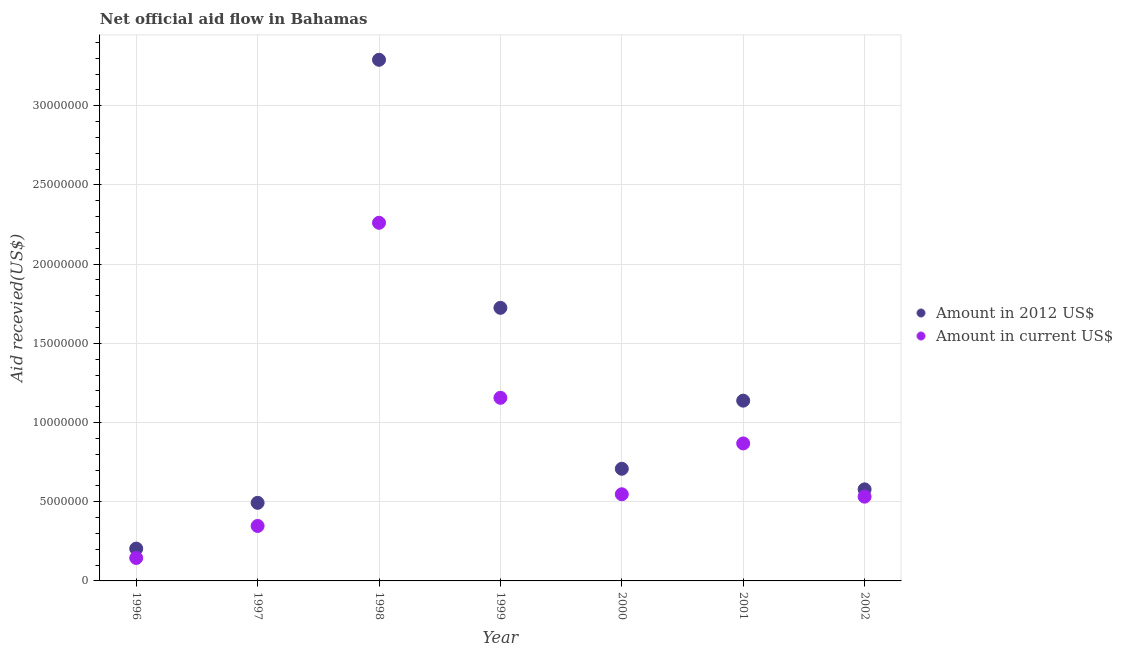What is the amount of aid received(expressed in 2012 us$) in 1997?
Ensure brevity in your answer.  4.93e+06. Across all years, what is the maximum amount of aid received(expressed in 2012 us$)?
Provide a succinct answer. 3.29e+07. Across all years, what is the minimum amount of aid received(expressed in us$)?
Keep it short and to the point. 1.45e+06. In which year was the amount of aid received(expressed in us$) minimum?
Your answer should be compact. 1996. What is the total amount of aid received(expressed in us$) in the graph?
Offer a terse response. 5.86e+07. What is the difference between the amount of aid received(expressed in us$) in 1996 and that in 2001?
Your response must be concise. -7.23e+06. What is the difference between the amount of aid received(expressed in 2012 us$) in 2001 and the amount of aid received(expressed in us$) in 1998?
Provide a succinct answer. -1.12e+07. What is the average amount of aid received(expressed in 2012 us$) per year?
Ensure brevity in your answer.  1.16e+07. In the year 2002, what is the difference between the amount of aid received(expressed in us$) and amount of aid received(expressed in 2012 us$)?
Offer a terse response. -4.60e+05. What is the ratio of the amount of aid received(expressed in us$) in 1997 to that in 2000?
Provide a succinct answer. 0.63. Is the amount of aid received(expressed in 2012 us$) in 1998 less than that in 2001?
Your answer should be very brief. No. What is the difference between the highest and the second highest amount of aid received(expressed in us$)?
Offer a very short reply. 1.10e+07. What is the difference between the highest and the lowest amount of aid received(expressed in 2012 us$)?
Your response must be concise. 3.09e+07. Is the amount of aid received(expressed in 2012 us$) strictly greater than the amount of aid received(expressed in us$) over the years?
Offer a terse response. Yes. Is the amount of aid received(expressed in 2012 us$) strictly less than the amount of aid received(expressed in us$) over the years?
Provide a succinct answer. No. How many years are there in the graph?
Your answer should be compact. 7. What is the difference between two consecutive major ticks on the Y-axis?
Keep it short and to the point. 5.00e+06. Where does the legend appear in the graph?
Provide a succinct answer. Center right. How are the legend labels stacked?
Offer a terse response. Vertical. What is the title of the graph?
Your answer should be compact. Net official aid flow in Bahamas. What is the label or title of the Y-axis?
Make the answer very short. Aid recevied(US$). What is the Aid recevied(US$) of Amount in 2012 US$ in 1996?
Your response must be concise. 2.04e+06. What is the Aid recevied(US$) of Amount in current US$ in 1996?
Provide a succinct answer. 1.45e+06. What is the Aid recevied(US$) of Amount in 2012 US$ in 1997?
Your answer should be very brief. 4.93e+06. What is the Aid recevied(US$) of Amount in current US$ in 1997?
Offer a very short reply. 3.47e+06. What is the Aid recevied(US$) of Amount in 2012 US$ in 1998?
Give a very brief answer. 3.29e+07. What is the Aid recevied(US$) in Amount in current US$ in 1998?
Provide a short and direct response. 2.26e+07. What is the Aid recevied(US$) of Amount in 2012 US$ in 1999?
Provide a short and direct response. 1.72e+07. What is the Aid recevied(US$) in Amount in current US$ in 1999?
Make the answer very short. 1.16e+07. What is the Aid recevied(US$) of Amount in 2012 US$ in 2000?
Give a very brief answer. 7.08e+06. What is the Aid recevied(US$) in Amount in current US$ in 2000?
Provide a succinct answer. 5.47e+06. What is the Aid recevied(US$) in Amount in 2012 US$ in 2001?
Provide a succinct answer. 1.14e+07. What is the Aid recevied(US$) in Amount in current US$ in 2001?
Give a very brief answer. 8.68e+06. What is the Aid recevied(US$) of Amount in 2012 US$ in 2002?
Ensure brevity in your answer.  5.78e+06. What is the Aid recevied(US$) in Amount in current US$ in 2002?
Offer a terse response. 5.32e+06. Across all years, what is the maximum Aid recevied(US$) of Amount in 2012 US$?
Your answer should be very brief. 3.29e+07. Across all years, what is the maximum Aid recevied(US$) in Amount in current US$?
Offer a very short reply. 2.26e+07. Across all years, what is the minimum Aid recevied(US$) in Amount in 2012 US$?
Offer a very short reply. 2.04e+06. Across all years, what is the minimum Aid recevied(US$) of Amount in current US$?
Your response must be concise. 1.45e+06. What is the total Aid recevied(US$) in Amount in 2012 US$ in the graph?
Offer a very short reply. 8.14e+07. What is the total Aid recevied(US$) of Amount in current US$ in the graph?
Provide a short and direct response. 5.86e+07. What is the difference between the Aid recevied(US$) of Amount in 2012 US$ in 1996 and that in 1997?
Give a very brief answer. -2.89e+06. What is the difference between the Aid recevied(US$) in Amount in current US$ in 1996 and that in 1997?
Offer a terse response. -2.02e+06. What is the difference between the Aid recevied(US$) of Amount in 2012 US$ in 1996 and that in 1998?
Offer a very short reply. -3.09e+07. What is the difference between the Aid recevied(US$) in Amount in current US$ in 1996 and that in 1998?
Make the answer very short. -2.12e+07. What is the difference between the Aid recevied(US$) in Amount in 2012 US$ in 1996 and that in 1999?
Your answer should be compact. -1.52e+07. What is the difference between the Aid recevied(US$) of Amount in current US$ in 1996 and that in 1999?
Ensure brevity in your answer.  -1.01e+07. What is the difference between the Aid recevied(US$) in Amount in 2012 US$ in 1996 and that in 2000?
Your response must be concise. -5.04e+06. What is the difference between the Aid recevied(US$) in Amount in current US$ in 1996 and that in 2000?
Give a very brief answer. -4.02e+06. What is the difference between the Aid recevied(US$) of Amount in 2012 US$ in 1996 and that in 2001?
Give a very brief answer. -9.34e+06. What is the difference between the Aid recevied(US$) of Amount in current US$ in 1996 and that in 2001?
Your response must be concise. -7.23e+06. What is the difference between the Aid recevied(US$) in Amount in 2012 US$ in 1996 and that in 2002?
Your answer should be very brief. -3.74e+06. What is the difference between the Aid recevied(US$) in Amount in current US$ in 1996 and that in 2002?
Keep it short and to the point. -3.87e+06. What is the difference between the Aid recevied(US$) in Amount in 2012 US$ in 1997 and that in 1998?
Offer a very short reply. -2.80e+07. What is the difference between the Aid recevied(US$) of Amount in current US$ in 1997 and that in 1998?
Ensure brevity in your answer.  -1.91e+07. What is the difference between the Aid recevied(US$) in Amount in 2012 US$ in 1997 and that in 1999?
Provide a short and direct response. -1.23e+07. What is the difference between the Aid recevied(US$) of Amount in current US$ in 1997 and that in 1999?
Ensure brevity in your answer.  -8.09e+06. What is the difference between the Aid recevied(US$) of Amount in 2012 US$ in 1997 and that in 2000?
Ensure brevity in your answer.  -2.15e+06. What is the difference between the Aid recevied(US$) of Amount in 2012 US$ in 1997 and that in 2001?
Give a very brief answer. -6.45e+06. What is the difference between the Aid recevied(US$) in Amount in current US$ in 1997 and that in 2001?
Make the answer very short. -5.21e+06. What is the difference between the Aid recevied(US$) in Amount in 2012 US$ in 1997 and that in 2002?
Provide a succinct answer. -8.50e+05. What is the difference between the Aid recevied(US$) in Amount in current US$ in 1997 and that in 2002?
Your answer should be compact. -1.85e+06. What is the difference between the Aid recevied(US$) in Amount in 2012 US$ in 1998 and that in 1999?
Your response must be concise. 1.57e+07. What is the difference between the Aid recevied(US$) in Amount in current US$ in 1998 and that in 1999?
Your answer should be very brief. 1.10e+07. What is the difference between the Aid recevied(US$) of Amount in 2012 US$ in 1998 and that in 2000?
Your answer should be compact. 2.58e+07. What is the difference between the Aid recevied(US$) of Amount in current US$ in 1998 and that in 2000?
Your answer should be very brief. 1.71e+07. What is the difference between the Aid recevied(US$) of Amount in 2012 US$ in 1998 and that in 2001?
Give a very brief answer. 2.15e+07. What is the difference between the Aid recevied(US$) in Amount in current US$ in 1998 and that in 2001?
Your answer should be very brief. 1.39e+07. What is the difference between the Aid recevied(US$) of Amount in 2012 US$ in 1998 and that in 2002?
Give a very brief answer. 2.71e+07. What is the difference between the Aid recevied(US$) of Amount in current US$ in 1998 and that in 2002?
Give a very brief answer. 1.73e+07. What is the difference between the Aid recevied(US$) of Amount in 2012 US$ in 1999 and that in 2000?
Your response must be concise. 1.02e+07. What is the difference between the Aid recevied(US$) in Amount in current US$ in 1999 and that in 2000?
Provide a succinct answer. 6.09e+06. What is the difference between the Aid recevied(US$) of Amount in 2012 US$ in 1999 and that in 2001?
Keep it short and to the point. 5.86e+06. What is the difference between the Aid recevied(US$) in Amount in current US$ in 1999 and that in 2001?
Make the answer very short. 2.88e+06. What is the difference between the Aid recevied(US$) in Amount in 2012 US$ in 1999 and that in 2002?
Offer a terse response. 1.15e+07. What is the difference between the Aid recevied(US$) in Amount in current US$ in 1999 and that in 2002?
Make the answer very short. 6.24e+06. What is the difference between the Aid recevied(US$) of Amount in 2012 US$ in 2000 and that in 2001?
Make the answer very short. -4.30e+06. What is the difference between the Aid recevied(US$) in Amount in current US$ in 2000 and that in 2001?
Make the answer very short. -3.21e+06. What is the difference between the Aid recevied(US$) of Amount in 2012 US$ in 2000 and that in 2002?
Your answer should be compact. 1.30e+06. What is the difference between the Aid recevied(US$) of Amount in current US$ in 2000 and that in 2002?
Provide a succinct answer. 1.50e+05. What is the difference between the Aid recevied(US$) in Amount in 2012 US$ in 2001 and that in 2002?
Offer a terse response. 5.60e+06. What is the difference between the Aid recevied(US$) of Amount in current US$ in 2001 and that in 2002?
Make the answer very short. 3.36e+06. What is the difference between the Aid recevied(US$) in Amount in 2012 US$ in 1996 and the Aid recevied(US$) in Amount in current US$ in 1997?
Make the answer very short. -1.43e+06. What is the difference between the Aid recevied(US$) of Amount in 2012 US$ in 1996 and the Aid recevied(US$) of Amount in current US$ in 1998?
Your response must be concise. -2.06e+07. What is the difference between the Aid recevied(US$) of Amount in 2012 US$ in 1996 and the Aid recevied(US$) of Amount in current US$ in 1999?
Your response must be concise. -9.52e+06. What is the difference between the Aid recevied(US$) in Amount in 2012 US$ in 1996 and the Aid recevied(US$) in Amount in current US$ in 2000?
Your answer should be compact. -3.43e+06. What is the difference between the Aid recevied(US$) in Amount in 2012 US$ in 1996 and the Aid recevied(US$) in Amount in current US$ in 2001?
Your answer should be compact. -6.64e+06. What is the difference between the Aid recevied(US$) in Amount in 2012 US$ in 1996 and the Aid recevied(US$) in Amount in current US$ in 2002?
Keep it short and to the point. -3.28e+06. What is the difference between the Aid recevied(US$) of Amount in 2012 US$ in 1997 and the Aid recevied(US$) of Amount in current US$ in 1998?
Provide a short and direct response. -1.77e+07. What is the difference between the Aid recevied(US$) of Amount in 2012 US$ in 1997 and the Aid recevied(US$) of Amount in current US$ in 1999?
Keep it short and to the point. -6.63e+06. What is the difference between the Aid recevied(US$) in Amount in 2012 US$ in 1997 and the Aid recevied(US$) in Amount in current US$ in 2000?
Make the answer very short. -5.40e+05. What is the difference between the Aid recevied(US$) in Amount in 2012 US$ in 1997 and the Aid recevied(US$) in Amount in current US$ in 2001?
Your answer should be very brief. -3.75e+06. What is the difference between the Aid recevied(US$) of Amount in 2012 US$ in 1997 and the Aid recevied(US$) of Amount in current US$ in 2002?
Your answer should be compact. -3.90e+05. What is the difference between the Aid recevied(US$) in Amount in 2012 US$ in 1998 and the Aid recevied(US$) in Amount in current US$ in 1999?
Offer a terse response. 2.13e+07. What is the difference between the Aid recevied(US$) in Amount in 2012 US$ in 1998 and the Aid recevied(US$) in Amount in current US$ in 2000?
Your answer should be very brief. 2.74e+07. What is the difference between the Aid recevied(US$) of Amount in 2012 US$ in 1998 and the Aid recevied(US$) of Amount in current US$ in 2001?
Keep it short and to the point. 2.42e+07. What is the difference between the Aid recevied(US$) of Amount in 2012 US$ in 1998 and the Aid recevied(US$) of Amount in current US$ in 2002?
Make the answer very short. 2.76e+07. What is the difference between the Aid recevied(US$) in Amount in 2012 US$ in 1999 and the Aid recevied(US$) in Amount in current US$ in 2000?
Your answer should be very brief. 1.18e+07. What is the difference between the Aid recevied(US$) in Amount in 2012 US$ in 1999 and the Aid recevied(US$) in Amount in current US$ in 2001?
Keep it short and to the point. 8.56e+06. What is the difference between the Aid recevied(US$) in Amount in 2012 US$ in 1999 and the Aid recevied(US$) in Amount in current US$ in 2002?
Your response must be concise. 1.19e+07. What is the difference between the Aid recevied(US$) of Amount in 2012 US$ in 2000 and the Aid recevied(US$) of Amount in current US$ in 2001?
Offer a very short reply. -1.60e+06. What is the difference between the Aid recevied(US$) of Amount in 2012 US$ in 2000 and the Aid recevied(US$) of Amount in current US$ in 2002?
Your response must be concise. 1.76e+06. What is the difference between the Aid recevied(US$) of Amount in 2012 US$ in 2001 and the Aid recevied(US$) of Amount in current US$ in 2002?
Provide a succinct answer. 6.06e+06. What is the average Aid recevied(US$) in Amount in 2012 US$ per year?
Your answer should be compact. 1.16e+07. What is the average Aid recevied(US$) of Amount in current US$ per year?
Ensure brevity in your answer.  8.37e+06. In the year 1996, what is the difference between the Aid recevied(US$) in Amount in 2012 US$ and Aid recevied(US$) in Amount in current US$?
Make the answer very short. 5.90e+05. In the year 1997, what is the difference between the Aid recevied(US$) in Amount in 2012 US$ and Aid recevied(US$) in Amount in current US$?
Make the answer very short. 1.46e+06. In the year 1998, what is the difference between the Aid recevied(US$) of Amount in 2012 US$ and Aid recevied(US$) of Amount in current US$?
Provide a short and direct response. 1.03e+07. In the year 1999, what is the difference between the Aid recevied(US$) of Amount in 2012 US$ and Aid recevied(US$) of Amount in current US$?
Your response must be concise. 5.68e+06. In the year 2000, what is the difference between the Aid recevied(US$) of Amount in 2012 US$ and Aid recevied(US$) of Amount in current US$?
Ensure brevity in your answer.  1.61e+06. In the year 2001, what is the difference between the Aid recevied(US$) of Amount in 2012 US$ and Aid recevied(US$) of Amount in current US$?
Offer a very short reply. 2.70e+06. What is the ratio of the Aid recevied(US$) of Amount in 2012 US$ in 1996 to that in 1997?
Your answer should be very brief. 0.41. What is the ratio of the Aid recevied(US$) in Amount in current US$ in 1996 to that in 1997?
Your response must be concise. 0.42. What is the ratio of the Aid recevied(US$) in Amount in 2012 US$ in 1996 to that in 1998?
Your answer should be very brief. 0.06. What is the ratio of the Aid recevied(US$) of Amount in current US$ in 1996 to that in 1998?
Ensure brevity in your answer.  0.06. What is the ratio of the Aid recevied(US$) of Amount in 2012 US$ in 1996 to that in 1999?
Make the answer very short. 0.12. What is the ratio of the Aid recevied(US$) in Amount in current US$ in 1996 to that in 1999?
Ensure brevity in your answer.  0.13. What is the ratio of the Aid recevied(US$) of Amount in 2012 US$ in 1996 to that in 2000?
Your answer should be compact. 0.29. What is the ratio of the Aid recevied(US$) in Amount in current US$ in 1996 to that in 2000?
Your answer should be very brief. 0.27. What is the ratio of the Aid recevied(US$) of Amount in 2012 US$ in 1996 to that in 2001?
Provide a succinct answer. 0.18. What is the ratio of the Aid recevied(US$) of Amount in current US$ in 1996 to that in 2001?
Your response must be concise. 0.17. What is the ratio of the Aid recevied(US$) of Amount in 2012 US$ in 1996 to that in 2002?
Your answer should be very brief. 0.35. What is the ratio of the Aid recevied(US$) in Amount in current US$ in 1996 to that in 2002?
Provide a succinct answer. 0.27. What is the ratio of the Aid recevied(US$) of Amount in 2012 US$ in 1997 to that in 1998?
Offer a very short reply. 0.15. What is the ratio of the Aid recevied(US$) in Amount in current US$ in 1997 to that in 1998?
Provide a short and direct response. 0.15. What is the ratio of the Aid recevied(US$) in Amount in 2012 US$ in 1997 to that in 1999?
Provide a short and direct response. 0.29. What is the ratio of the Aid recevied(US$) of Amount in current US$ in 1997 to that in 1999?
Your answer should be very brief. 0.3. What is the ratio of the Aid recevied(US$) in Amount in 2012 US$ in 1997 to that in 2000?
Ensure brevity in your answer.  0.7. What is the ratio of the Aid recevied(US$) in Amount in current US$ in 1997 to that in 2000?
Your answer should be very brief. 0.63. What is the ratio of the Aid recevied(US$) in Amount in 2012 US$ in 1997 to that in 2001?
Provide a succinct answer. 0.43. What is the ratio of the Aid recevied(US$) of Amount in current US$ in 1997 to that in 2001?
Your answer should be compact. 0.4. What is the ratio of the Aid recevied(US$) in Amount in 2012 US$ in 1997 to that in 2002?
Provide a succinct answer. 0.85. What is the ratio of the Aid recevied(US$) of Amount in current US$ in 1997 to that in 2002?
Ensure brevity in your answer.  0.65. What is the ratio of the Aid recevied(US$) of Amount in 2012 US$ in 1998 to that in 1999?
Make the answer very short. 1.91. What is the ratio of the Aid recevied(US$) of Amount in current US$ in 1998 to that in 1999?
Provide a short and direct response. 1.96. What is the ratio of the Aid recevied(US$) in Amount in 2012 US$ in 1998 to that in 2000?
Offer a very short reply. 4.65. What is the ratio of the Aid recevied(US$) of Amount in current US$ in 1998 to that in 2000?
Make the answer very short. 4.13. What is the ratio of the Aid recevied(US$) of Amount in 2012 US$ in 1998 to that in 2001?
Your answer should be compact. 2.89. What is the ratio of the Aid recevied(US$) in Amount in current US$ in 1998 to that in 2001?
Offer a terse response. 2.6. What is the ratio of the Aid recevied(US$) of Amount in 2012 US$ in 1998 to that in 2002?
Give a very brief answer. 5.69. What is the ratio of the Aid recevied(US$) of Amount in current US$ in 1998 to that in 2002?
Offer a terse response. 4.25. What is the ratio of the Aid recevied(US$) in Amount in 2012 US$ in 1999 to that in 2000?
Make the answer very short. 2.44. What is the ratio of the Aid recevied(US$) in Amount in current US$ in 1999 to that in 2000?
Your answer should be very brief. 2.11. What is the ratio of the Aid recevied(US$) in Amount in 2012 US$ in 1999 to that in 2001?
Keep it short and to the point. 1.51. What is the ratio of the Aid recevied(US$) of Amount in current US$ in 1999 to that in 2001?
Give a very brief answer. 1.33. What is the ratio of the Aid recevied(US$) of Amount in 2012 US$ in 1999 to that in 2002?
Provide a short and direct response. 2.98. What is the ratio of the Aid recevied(US$) of Amount in current US$ in 1999 to that in 2002?
Offer a terse response. 2.17. What is the ratio of the Aid recevied(US$) in Amount in 2012 US$ in 2000 to that in 2001?
Give a very brief answer. 0.62. What is the ratio of the Aid recevied(US$) in Amount in current US$ in 2000 to that in 2001?
Make the answer very short. 0.63. What is the ratio of the Aid recevied(US$) of Amount in 2012 US$ in 2000 to that in 2002?
Provide a short and direct response. 1.22. What is the ratio of the Aid recevied(US$) of Amount in current US$ in 2000 to that in 2002?
Make the answer very short. 1.03. What is the ratio of the Aid recevied(US$) in Amount in 2012 US$ in 2001 to that in 2002?
Provide a short and direct response. 1.97. What is the ratio of the Aid recevied(US$) of Amount in current US$ in 2001 to that in 2002?
Ensure brevity in your answer.  1.63. What is the difference between the highest and the second highest Aid recevied(US$) in Amount in 2012 US$?
Provide a short and direct response. 1.57e+07. What is the difference between the highest and the second highest Aid recevied(US$) in Amount in current US$?
Provide a succinct answer. 1.10e+07. What is the difference between the highest and the lowest Aid recevied(US$) of Amount in 2012 US$?
Your response must be concise. 3.09e+07. What is the difference between the highest and the lowest Aid recevied(US$) in Amount in current US$?
Your answer should be very brief. 2.12e+07. 